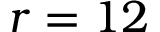Convert formula to latex. <formula><loc_0><loc_0><loc_500><loc_500>r = 1 2</formula> 